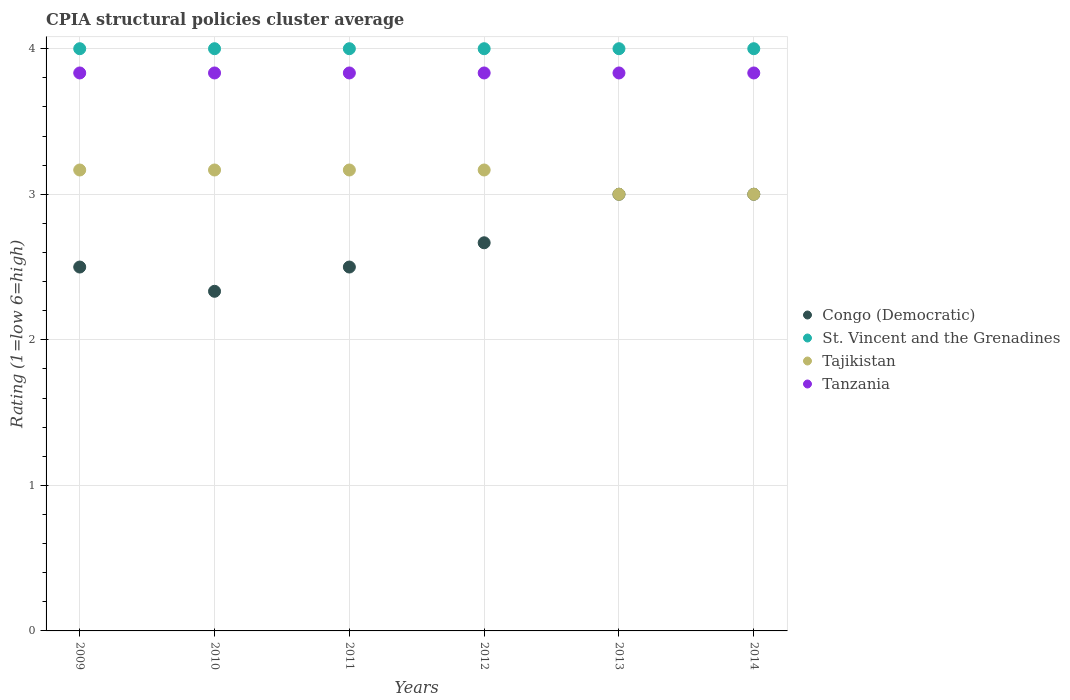How many different coloured dotlines are there?
Your response must be concise. 4. Across all years, what is the maximum CPIA rating in Tajikistan?
Provide a short and direct response. 3.17. Across all years, what is the minimum CPIA rating in Tanzania?
Give a very brief answer. 3.83. In which year was the CPIA rating in Congo (Democratic) maximum?
Ensure brevity in your answer.  2013. In which year was the CPIA rating in St. Vincent and the Grenadines minimum?
Provide a succinct answer. 2009. What is the difference between the CPIA rating in Congo (Democratic) in 2010 and that in 2014?
Provide a short and direct response. -0.67. What is the difference between the CPIA rating in Tanzania in 2013 and the CPIA rating in Congo (Democratic) in 2009?
Your answer should be compact. 1.33. What is the average CPIA rating in Congo (Democratic) per year?
Your answer should be compact. 2.67. In the year 2009, what is the difference between the CPIA rating in Congo (Democratic) and CPIA rating in Tanzania?
Offer a very short reply. -1.33. Is the difference between the CPIA rating in Congo (Democratic) in 2010 and 2012 greater than the difference between the CPIA rating in Tanzania in 2010 and 2012?
Keep it short and to the point. No. What is the difference between the highest and the second highest CPIA rating in Tajikistan?
Your answer should be compact. 0. What is the difference between the highest and the lowest CPIA rating in St. Vincent and the Grenadines?
Provide a succinct answer. 0. In how many years, is the CPIA rating in Tanzania greater than the average CPIA rating in Tanzania taken over all years?
Make the answer very short. 5. Is it the case that in every year, the sum of the CPIA rating in Congo (Democratic) and CPIA rating in Tanzania  is greater than the CPIA rating in Tajikistan?
Give a very brief answer. Yes. Is the CPIA rating in Tanzania strictly greater than the CPIA rating in Congo (Democratic) over the years?
Provide a succinct answer. Yes. How many dotlines are there?
Your answer should be compact. 4. How many years are there in the graph?
Your answer should be compact. 6. Are the values on the major ticks of Y-axis written in scientific E-notation?
Provide a short and direct response. No. Does the graph contain any zero values?
Your answer should be compact. No. Does the graph contain grids?
Ensure brevity in your answer.  Yes. How many legend labels are there?
Ensure brevity in your answer.  4. What is the title of the graph?
Your response must be concise. CPIA structural policies cluster average. What is the label or title of the X-axis?
Give a very brief answer. Years. What is the Rating (1=low 6=high) of Congo (Democratic) in 2009?
Offer a very short reply. 2.5. What is the Rating (1=low 6=high) of St. Vincent and the Grenadines in 2009?
Your answer should be very brief. 4. What is the Rating (1=low 6=high) in Tajikistan in 2009?
Give a very brief answer. 3.17. What is the Rating (1=low 6=high) of Tanzania in 2009?
Offer a terse response. 3.83. What is the Rating (1=low 6=high) of Congo (Democratic) in 2010?
Provide a short and direct response. 2.33. What is the Rating (1=low 6=high) in Tajikistan in 2010?
Provide a succinct answer. 3.17. What is the Rating (1=low 6=high) in Tanzania in 2010?
Your answer should be very brief. 3.83. What is the Rating (1=low 6=high) in St. Vincent and the Grenadines in 2011?
Ensure brevity in your answer.  4. What is the Rating (1=low 6=high) of Tajikistan in 2011?
Provide a succinct answer. 3.17. What is the Rating (1=low 6=high) in Tanzania in 2011?
Your answer should be very brief. 3.83. What is the Rating (1=low 6=high) in Congo (Democratic) in 2012?
Your answer should be very brief. 2.67. What is the Rating (1=low 6=high) of Tajikistan in 2012?
Your response must be concise. 3.17. What is the Rating (1=low 6=high) in Tanzania in 2012?
Offer a terse response. 3.83. What is the Rating (1=low 6=high) in Congo (Democratic) in 2013?
Keep it short and to the point. 3. What is the Rating (1=low 6=high) of Tajikistan in 2013?
Your response must be concise. 3. What is the Rating (1=low 6=high) in Tanzania in 2013?
Ensure brevity in your answer.  3.83. What is the Rating (1=low 6=high) of Congo (Democratic) in 2014?
Provide a short and direct response. 3. What is the Rating (1=low 6=high) of Tajikistan in 2014?
Give a very brief answer. 3. What is the Rating (1=low 6=high) in Tanzania in 2014?
Make the answer very short. 3.83. Across all years, what is the maximum Rating (1=low 6=high) in Congo (Democratic)?
Keep it short and to the point. 3. Across all years, what is the maximum Rating (1=low 6=high) of St. Vincent and the Grenadines?
Your answer should be compact. 4. Across all years, what is the maximum Rating (1=low 6=high) of Tajikistan?
Make the answer very short. 3.17. Across all years, what is the maximum Rating (1=low 6=high) in Tanzania?
Keep it short and to the point. 3.83. Across all years, what is the minimum Rating (1=low 6=high) of Congo (Democratic)?
Give a very brief answer. 2.33. Across all years, what is the minimum Rating (1=low 6=high) of St. Vincent and the Grenadines?
Ensure brevity in your answer.  4. Across all years, what is the minimum Rating (1=low 6=high) in Tanzania?
Offer a terse response. 3.83. What is the total Rating (1=low 6=high) of Congo (Democratic) in the graph?
Provide a short and direct response. 16. What is the total Rating (1=low 6=high) in Tajikistan in the graph?
Ensure brevity in your answer.  18.67. What is the difference between the Rating (1=low 6=high) in Tanzania in 2009 and that in 2010?
Offer a terse response. 0. What is the difference between the Rating (1=low 6=high) of Congo (Democratic) in 2009 and that in 2012?
Provide a short and direct response. -0.17. What is the difference between the Rating (1=low 6=high) in Congo (Democratic) in 2009 and that in 2013?
Provide a short and direct response. -0.5. What is the difference between the Rating (1=low 6=high) of St. Vincent and the Grenadines in 2009 and that in 2013?
Offer a terse response. 0. What is the difference between the Rating (1=low 6=high) in Tajikistan in 2009 and that in 2013?
Offer a terse response. 0.17. What is the difference between the Rating (1=low 6=high) in Congo (Democratic) in 2009 and that in 2014?
Keep it short and to the point. -0.5. What is the difference between the Rating (1=low 6=high) in St. Vincent and the Grenadines in 2009 and that in 2014?
Offer a very short reply. 0. What is the difference between the Rating (1=low 6=high) in St. Vincent and the Grenadines in 2010 and that in 2011?
Your answer should be very brief. 0. What is the difference between the Rating (1=low 6=high) of Tanzania in 2010 and that in 2011?
Ensure brevity in your answer.  0. What is the difference between the Rating (1=low 6=high) in Tajikistan in 2010 and that in 2012?
Give a very brief answer. 0. What is the difference between the Rating (1=low 6=high) in Tanzania in 2010 and that in 2012?
Your response must be concise. 0. What is the difference between the Rating (1=low 6=high) in Congo (Democratic) in 2010 and that in 2013?
Give a very brief answer. -0.67. What is the difference between the Rating (1=low 6=high) of St. Vincent and the Grenadines in 2010 and that in 2013?
Provide a succinct answer. 0. What is the difference between the Rating (1=low 6=high) in Tajikistan in 2010 and that in 2013?
Make the answer very short. 0.17. What is the difference between the Rating (1=low 6=high) in Congo (Democratic) in 2010 and that in 2014?
Provide a succinct answer. -0.67. What is the difference between the Rating (1=low 6=high) of St. Vincent and the Grenadines in 2010 and that in 2014?
Offer a very short reply. 0. What is the difference between the Rating (1=low 6=high) in Tanzania in 2011 and that in 2012?
Your answer should be compact. 0. What is the difference between the Rating (1=low 6=high) in Tanzania in 2011 and that in 2013?
Provide a succinct answer. 0. What is the difference between the Rating (1=low 6=high) of Congo (Democratic) in 2011 and that in 2014?
Offer a very short reply. -0.5. What is the difference between the Rating (1=low 6=high) in St. Vincent and the Grenadines in 2011 and that in 2014?
Make the answer very short. 0. What is the difference between the Rating (1=low 6=high) in Tajikistan in 2011 and that in 2014?
Keep it short and to the point. 0.17. What is the difference between the Rating (1=low 6=high) of Tanzania in 2011 and that in 2014?
Your response must be concise. 0. What is the difference between the Rating (1=low 6=high) in St. Vincent and the Grenadines in 2012 and that in 2013?
Keep it short and to the point. 0. What is the difference between the Rating (1=low 6=high) of St. Vincent and the Grenadines in 2012 and that in 2014?
Your answer should be very brief. 0. What is the difference between the Rating (1=low 6=high) in Tajikistan in 2012 and that in 2014?
Provide a short and direct response. 0.17. What is the difference between the Rating (1=low 6=high) of Tanzania in 2012 and that in 2014?
Your answer should be very brief. 0. What is the difference between the Rating (1=low 6=high) of Congo (Democratic) in 2013 and that in 2014?
Your answer should be very brief. 0. What is the difference between the Rating (1=low 6=high) in Tajikistan in 2013 and that in 2014?
Offer a very short reply. 0. What is the difference between the Rating (1=low 6=high) in Congo (Democratic) in 2009 and the Rating (1=low 6=high) in Tajikistan in 2010?
Keep it short and to the point. -0.67. What is the difference between the Rating (1=low 6=high) in Congo (Democratic) in 2009 and the Rating (1=low 6=high) in Tanzania in 2010?
Provide a succinct answer. -1.33. What is the difference between the Rating (1=low 6=high) in Congo (Democratic) in 2009 and the Rating (1=low 6=high) in St. Vincent and the Grenadines in 2011?
Your response must be concise. -1.5. What is the difference between the Rating (1=low 6=high) in Congo (Democratic) in 2009 and the Rating (1=low 6=high) in Tanzania in 2011?
Ensure brevity in your answer.  -1.33. What is the difference between the Rating (1=low 6=high) of St. Vincent and the Grenadines in 2009 and the Rating (1=low 6=high) of Tajikistan in 2011?
Give a very brief answer. 0.83. What is the difference between the Rating (1=low 6=high) in Congo (Democratic) in 2009 and the Rating (1=low 6=high) in St. Vincent and the Grenadines in 2012?
Provide a short and direct response. -1.5. What is the difference between the Rating (1=low 6=high) of Congo (Democratic) in 2009 and the Rating (1=low 6=high) of Tanzania in 2012?
Provide a succinct answer. -1.33. What is the difference between the Rating (1=low 6=high) of St. Vincent and the Grenadines in 2009 and the Rating (1=low 6=high) of Tanzania in 2012?
Keep it short and to the point. 0.17. What is the difference between the Rating (1=low 6=high) of Tajikistan in 2009 and the Rating (1=low 6=high) of Tanzania in 2012?
Provide a succinct answer. -0.67. What is the difference between the Rating (1=low 6=high) in Congo (Democratic) in 2009 and the Rating (1=low 6=high) in St. Vincent and the Grenadines in 2013?
Offer a terse response. -1.5. What is the difference between the Rating (1=low 6=high) in Congo (Democratic) in 2009 and the Rating (1=low 6=high) in Tajikistan in 2013?
Provide a succinct answer. -0.5. What is the difference between the Rating (1=low 6=high) in Congo (Democratic) in 2009 and the Rating (1=low 6=high) in Tanzania in 2013?
Give a very brief answer. -1.33. What is the difference between the Rating (1=low 6=high) in St. Vincent and the Grenadines in 2009 and the Rating (1=low 6=high) in Tanzania in 2013?
Give a very brief answer. 0.17. What is the difference between the Rating (1=low 6=high) of Tajikistan in 2009 and the Rating (1=low 6=high) of Tanzania in 2013?
Your answer should be compact. -0.67. What is the difference between the Rating (1=low 6=high) in Congo (Democratic) in 2009 and the Rating (1=low 6=high) in St. Vincent and the Grenadines in 2014?
Give a very brief answer. -1.5. What is the difference between the Rating (1=low 6=high) of Congo (Democratic) in 2009 and the Rating (1=low 6=high) of Tanzania in 2014?
Keep it short and to the point. -1.33. What is the difference between the Rating (1=low 6=high) of Tajikistan in 2009 and the Rating (1=low 6=high) of Tanzania in 2014?
Give a very brief answer. -0.67. What is the difference between the Rating (1=low 6=high) in Congo (Democratic) in 2010 and the Rating (1=low 6=high) in St. Vincent and the Grenadines in 2011?
Provide a succinct answer. -1.67. What is the difference between the Rating (1=low 6=high) in Congo (Democratic) in 2010 and the Rating (1=low 6=high) in Tajikistan in 2011?
Keep it short and to the point. -0.83. What is the difference between the Rating (1=low 6=high) in Congo (Democratic) in 2010 and the Rating (1=low 6=high) in Tanzania in 2011?
Provide a succinct answer. -1.5. What is the difference between the Rating (1=low 6=high) in St. Vincent and the Grenadines in 2010 and the Rating (1=low 6=high) in Tajikistan in 2011?
Provide a short and direct response. 0.83. What is the difference between the Rating (1=low 6=high) of St. Vincent and the Grenadines in 2010 and the Rating (1=low 6=high) of Tanzania in 2011?
Make the answer very short. 0.17. What is the difference between the Rating (1=low 6=high) of Tajikistan in 2010 and the Rating (1=low 6=high) of Tanzania in 2011?
Ensure brevity in your answer.  -0.67. What is the difference between the Rating (1=low 6=high) in Congo (Democratic) in 2010 and the Rating (1=low 6=high) in St. Vincent and the Grenadines in 2012?
Your response must be concise. -1.67. What is the difference between the Rating (1=low 6=high) in Congo (Democratic) in 2010 and the Rating (1=low 6=high) in Tanzania in 2012?
Make the answer very short. -1.5. What is the difference between the Rating (1=low 6=high) of St. Vincent and the Grenadines in 2010 and the Rating (1=low 6=high) of Tajikistan in 2012?
Keep it short and to the point. 0.83. What is the difference between the Rating (1=low 6=high) in St. Vincent and the Grenadines in 2010 and the Rating (1=low 6=high) in Tanzania in 2012?
Your answer should be very brief. 0.17. What is the difference between the Rating (1=low 6=high) of Tajikistan in 2010 and the Rating (1=low 6=high) of Tanzania in 2012?
Give a very brief answer. -0.67. What is the difference between the Rating (1=low 6=high) in Congo (Democratic) in 2010 and the Rating (1=low 6=high) in St. Vincent and the Grenadines in 2013?
Provide a short and direct response. -1.67. What is the difference between the Rating (1=low 6=high) of Congo (Democratic) in 2010 and the Rating (1=low 6=high) of Tajikistan in 2013?
Ensure brevity in your answer.  -0.67. What is the difference between the Rating (1=low 6=high) in St. Vincent and the Grenadines in 2010 and the Rating (1=low 6=high) in Tajikistan in 2013?
Keep it short and to the point. 1. What is the difference between the Rating (1=low 6=high) of St. Vincent and the Grenadines in 2010 and the Rating (1=low 6=high) of Tanzania in 2013?
Keep it short and to the point. 0.17. What is the difference between the Rating (1=low 6=high) of Congo (Democratic) in 2010 and the Rating (1=low 6=high) of St. Vincent and the Grenadines in 2014?
Offer a terse response. -1.67. What is the difference between the Rating (1=low 6=high) in Congo (Democratic) in 2011 and the Rating (1=low 6=high) in St. Vincent and the Grenadines in 2012?
Make the answer very short. -1.5. What is the difference between the Rating (1=low 6=high) of Congo (Democratic) in 2011 and the Rating (1=low 6=high) of Tajikistan in 2012?
Ensure brevity in your answer.  -0.67. What is the difference between the Rating (1=low 6=high) of Congo (Democratic) in 2011 and the Rating (1=low 6=high) of Tanzania in 2012?
Your answer should be compact. -1.33. What is the difference between the Rating (1=low 6=high) in St. Vincent and the Grenadines in 2011 and the Rating (1=low 6=high) in Tajikistan in 2012?
Ensure brevity in your answer.  0.83. What is the difference between the Rating (1=low 6=high) of Congo (Democratic) in 2011 and the Rating (1=low 6=high) of Tanzania in 2013?
Give a very brief answer. -1.33. What is the difference between the Rating (1=low 6=high) of St. Vincent and the Grenadines in 2011 and the Rating (1=low 6=high) of Tajikistan in 2013?
Make the answer very short. 1. What is the difference between the Rating (1=low 6=high) in Tajikistan in 2011 and the Rating (1=low 6=high) in Tanzania in 2013?
Your answer should be very brief. -0.67. What is the difference between the Rating (1=low 6=high) of Congo (Democratic) in 2011 and the Rating (1=low 6=high) of St. Vincent and the Grenadines in 2014?
Offer a terse response. -1.5. What is the difference between the Rating (1=low 6=high) in Congo (Democratic) in 2011 and the Rating (1=low 6=high) in Tajikistan in 2014?
Make the answer very short. -0.5. What is the difference between the Rating (1=low 6=high) in Congo (Democratic) in 2011 and the Rating (1=low 6=high) in Tanzania in 2014?
Ensure brevity in your answer.  -1.33. What is the difference between the Rating (1=low 6=high) of St. Vincent and the Grenadines in 2011 and the Rating (1=low 6=high) of Tajikistan in 2014?
Provide a short and direct response. 1. What is the difference between the Rating (1=low 6=high) of Congo (Democratic) in 2012 and the Rating (1=low 6=high) of St. Vincent and the Grenadines in 2013?
Offer a very short reply. -1.33. What is the difference between the Rating (1=low 6=high) in Congo (Democratic) in 2012 and the Rating (1=low 6=high) in Tanzania in 2013?
Provide a succinct answer. -1.17. What is the difference between the Rating (1=low 6=high) of Tajikistan in 2012 and the Rating (1=low 6=high) of Tanzania in 2013?
Your answer should be very brief. -0.67. What is the difference between the Rating (1=low 6=high) in Congo (Democratic) in 2012 and the Rating (1=low 6=high) in St. Vincent and the Grenadines in 2014?
Your answer should be compact. -1.33. What is the difference between the Rating (1=low 6=high) in Congo (Democratic) in 2012 and the Rating (1=low 6=high) in Tajikistan in 2014?
Ensure brevity in your answer.  -0.33. What is the difference between the Rating (1=low 6=high) of Congo (Democratic) in 2012 and the Rating (1=low 6=high) of Tanzania in 2014?
Your answer should be compact. -1.17. What is the difference between the Rating (1=low 6=high) of St. Vincent and the Grenadines in 2012 and the Rating (1=low 6=high) of Tajikistan in 2014?
Provide a short and direct response. 1. What is the difference between the Rating (1=low 6=high) in St. Vincent and the Grenadines in 2013 and the Rating (1=low 6=high) in Tajikistan in 2014?
Give a very brief answer. 1. What is the difference between the Rating (1=low 6=high) in St. Vincent and the Grenadines in 2013 and the Rating (1=low 6=high) in Tanzania in 2014?
Your answer should be compact. 0.17. What is the difference between the Rating (1=low 6=high) of Tajikistan in 2013 and the Rating (1=low 6=high) of Tanzania in 2014?
Give a very brief answer. -0.83. What is the average Rating (1=low 6=high) in Congo (Democratic) per year?
Provide a succinct answer. 2.67. What is the average Rating (1=low 6=high) in St. Vincent and the Grenadines per year?
Your answer should be compact. 4. What is the average Rating (1=low 6=high) in Tajikistan per year?
Provide a succinct answer. 3.11. What is the average Rating (1=low 6=high) in Tanzania per year?
Give a very brief answer. 3.83. In the year 2009, what is the difference between the Rating (1=low 6=high) of Congo (Democratic) and Rating (1=low 6=high) of St. Vincent and the Grenadines?
Your answer should be compact. -1.5. In the year 2009, what is the difference between the Rating (1=low 6=high) in Congo (Democratic) and Rating (1=low 6=high) in Tanzania?
Your response must be concise. -1.33. In the year 2009, what is the difference between the Rating (1=low 6=high) of St. Vincent and the Grenadines and Rating (1=low 6=high) of Tajikistan?
Ensure brevity in your answer.  0.83. In the year 2009, what is the difference between the Rating (1=low 6=high) in St. Vincent and the Grenadines and Rating (1=low 6=high) in Tanzania?
Ensure brevity in your answer.  0.17. In the year 2010, what is the difference between the Rating (1=low 6=high) of Congo (Democratic) and Rating (1=low 6=high) of St. Vincent and the Grenadines?
Give a very brief answer. -1.67. In the year 2010, what is the difference between the Rating (1=low 6=high) of Congo (Democratic) and Rating (1=low 6=high) of Tanzania?
Your answer should be compact. -1.5. In the year 2011, what is the difference between the Rating (1=low 6=high) of Congo (Democratic) and Rating (1=low 6=high) of St. Vincent and the Grenadines?
Offer a terse response. -1.5. In the year 2011, what is the difference between the Rating (1=low 6=high) in Congo (Democratic) and Rating (1=low 6=high) in Tanzania?
Make the answer very short. -1.33. In the year 2011, what is the difference between the Rating (1=low 6=high) in Tajikistan and Rating (1=low 6=high) in Tanzania?
Offer a terse response. -0.67. In the year 2012, what is the difference between the Rating (1=low 6=high) of Congo (Democratic) and Rating (1=low 6=high) of St. Vincent and the Grenadines?
Offer a very short reply. -1.33. In the year 2012, what is the difference between the Rating (1=low 6=high) in Congo (Democratic) and Rating (1=low 6=high) in Tanzania?
Make the answer very short. -1.17. In the year 2012, what is the difference between the Rating (1=low 6=high) in St. Vincent and the Grenadines and Rating (1=low 6=high) in Tanzania?
Provide a short and direct response. 0.17. In the year 2013, what is the difference between the Rating (1=low 6=high) in Congo (Democratic) and Rating (1=low 6=high) in St. Vincent and the Grenadines?
Keep it short and to the point. -1. In the year 2014, what is the difference between the Rating (1=low 6=high) in Congo (Democratic) and Rating (1=low 6=high) in St. Vincent and the Grenadines?
Offer a very short reply. -1. In the year 2014, what is the difference between the Rating (1=low 6=high) in St. Vincent and the Grenadines and Rating (1=low 6=high) in Tajikistan?
Provide a succinct answer. 1. In the year 2014, what is the difference between the Rating (1=low 6=high) of St. Vincent and the Grenadines and Rating (1=low 6=high) of Tanzania?
Make the answer very short. 0.17. In the year 2014, what is the difference between the Rating (1=low 6=high) of Tajikistan and Rating (1=low 6=high) of Tanzania?
Give a very brief answer. -0.83. What is the ratio of the Rating (1=low 6=high) in Congo (Democratic) in 2009 to that in 2010?
Your answer should be compact. 1.07. What is the ratio of the Rating (1=low 6=high) in St. Vincent and the Grenadines in 2009 to that in 2010?
Your answer should be compact. 1. What is the ratio of the Rating (1=low 6=high) of Tanzania in 2009 to that in 2010?
Provide a short and direct response. 1. What is the ratio of the Rating (1=low 6=high) of St. Vincent and the Grenadines in 2009 to that in 2011?
Offer a very short reply. 1. What is the ratio of the Rating (1=low 6=high) of Tajikistan in 2009 to that in 2011?
Your response must be concise. 1. What is the ratio of the Rating (1=low 6=high) in St. Vincent and the Grenadines in 2009 to that in 2012?
Provide a short and direct response. 1. What is the ratio of the Rating (1=low 6=high) in Tanzania in 2009 to that in 2012?
Your answer should be very brief. 1. What is the ratio of the Rating (1=low 6=high) in St. Vincent and the Grenadines in 2009 to that in 2013?
Offer a very short reply. 1. What is the ratio of the Rating (1=low 6=high) in Tajikistan in 2009 to that in 2013?
Your response must be concise. 1.06. What is the ratio of the Rating (1=low 6=high) of Tanzania in 2009 to that in 2013?
Ensure brevity in your answer.  1. What is the ratio of the Rating (1=low 6=high) of Tajikistan in 2009 to that in 2014?
Make the answer very short. 1.06. What is the ratio of the Rating (1=low 6=high) in Tanzania in 2009 to that in 2014?
Offer a terse response. 1. What is the ratio of the Rating (1=low 6=high) in Congo (Democratic) in 2010 to that in 2011?
Your answer should be very brief. 0.93. What is the ratio of the Rating (1=low 6=high) in St. Vincent and the Grenadines in 2010 to that in 2011?
Ensure brevity in your answer.  1. What is the ratio of the Rating (1=low 6=high) in Tajikistan in 2010 to that in 2011?
Your response must be concise. 1. What is the ratio of the Rating (1=low 6=high) in Tanzania in 2010 to that in 2011?
Make the answer very short. 1. What is the ratio of the Rating (1=low 6=high) in St. Vincent and the Grenadines in 2010 to that in 2012?
Provide a succinct answer. 1. What is the ratio of the Rating (1=low 6=high) of Tajikistan in 2010 to that in 2012?
Offer a very short reply. 1. What is the ratio of the Rating (1=low 6=high) of Tanzania in 2010 to that in 2012?
Keep it short and to the point. 1. What is the ratio of the Rating (1=low 6=high) of Congo (Democratic) in 2010 to that in 2013?
Keep it short and to the point. 0.78. What is the ratio of the Rating (1=low 6=high) in St. Vincent and the Grenadines in 2010 to that in 2013?
Make the answer very short. 1. What is the ratio of the Rating (1=low 6=high) of Tajikistan in 2010 to that in 2013?
Provide a short and direct response. 1.06. What is the ratio of the Rating (1=low 6=high) in Tanzania in 2010 to that in 2013?
Give a very brief answer. 1. What is the ratio of the Rating (1=low 6=high) of St. Vincent and the Grenadines in 2010 to that in 2014?
Ensure brevity in your answer.  1. What is the ratio of the Rating (1=low 6=high) in Tajikistan in 2010 to that in 2014?
Offer a very short reply. 1.06. What is the ratio of the Rating (1=low 6=high) in Tanzania in 2010 to that in 2014?
Make the answer very short. 1. What is the ratio of the Rating (1=low 6=high) in Congo (Democratic) in 2011 to that in 2012?
Keep it short and to the point. 0.94. What is the ratio of the Rating (1=low 6=high) of Tajikistan in 2011 to that in 2013?
Your answer should be very brief. 1.06. What is the ratio of the Rating (1=low 6=high) of Tajikistan in 2011 to that in 2014?
Provide a short and direct response. 1.06. What is the ratio of the Rating (1=low 6=high) in St. Vincent and the Grenadines in 2012 to that in 2013?
Your answer should be compact. 1. What is the ratio of the Rating (1=low 6=high) in Tajikistan in 2012 to that in 2013?
Keep it short and to the point. 1.06. What is the ratio of the Rating (1=low 6=high) of Tajikistan in 2012 to that in 2014?
Provide a succinct answer. 1.06. What is the ratio of the Rating (1=low 6=high) in Tanzania in 2012 to that in 2014?
Give a very brief answer. 1. What is the ratio of the Rating (1=low 6=high) of Congo (Democratic) in 2013 to that in 2014?
Provide a short and direct response. 1. What is the ratio of the Rating (1=low 6=high) of St. Vincent and the Grenadines in 2013 to that in 2014?
Provide a short and direct response. 1. What is the ratio of the Rating (1=low 6=high) of Tajikistan in 2013 to that in 2014?
Your answer should be compact. 1. What is the ratio of the Rating (1=low 6=high) of Tanzania in 2013 to that in 2014?
Offer a terse response. 1. What is the difference between the highest and the second highest Rating (1=low 6=high) in St. Vincent and the Grenadines?
Make the answer very short. 0. What is the difference between the highest and the second highest Rating (1=low 6=high) in Tajikistan?
Offer a very short reply. 0. What is the difference between the highest and the lowest Rating (1=low 6=high) of Congo (Democratic)?
Offer a terse response. 0.67. What is the difference between the highest and the lowest Rating (1=low 6=high) of Tanzania?
Keep it short and to the point. 0. 